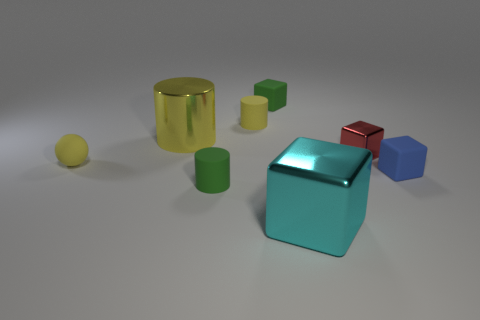Subtract all shiny cylinders. How many cylinders are left? 2 Add 1 large brown matte cubes. How many objects exist? 9 Subtract all balls. How many objects are left? 7 Subtract 3 cylinders. How many cylinders are left? 0 Subtract all tiny metallic objects. Subtract all large cyan cubes. How many objects are left? 6 Add 3 yellow rubber balls. How many yellow rubber balls are left? 4 Add 3 red blocks. How many red blocks exist? 4 Subtract all yellow cylinders. How many cylinders are left? 1 Subtract 0 brown spheres. How many objects are left? 8 Subtract all yellow cubes. Subtract all yellow balls. How many cubes are left? 4 